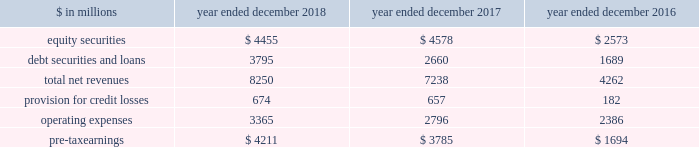The goldman sachs group , inc .
And subsidiaries management 2019s discussion and analysis net revenues in equities were $ 6.60 billion , 4% ( 4 % ) lower than 2016 , primarily due to lower commissions and fees , reflecting a decline in our listed cash equity volumes in the u.s .
Market volumes in the u.s .
Also declined .
In addition , net revenues in equities client execution were lower , reflecting lower net revenues in derivatives , partially offset by higher net revenues in cash products .
Net revenues in securities services were essentially unchanged .
Operating expenses were $ 9.69 billion for 2017 , essentially unchanged compared with 2016 , due to decreased compensation and benefits expenses , reflecting lower net revenues , largely offset by increased technology expenses , reflecting higher expenses related to cloud-based services and software depreciation , and increased consulting costs .
Pre-tax earnings were $ 2.21 billion in 2017 , 54% ( 54 % ) lower than 2016 .
Investing & lending investing & lending includes our investing activities and the origination of loans , including our relationship lending activities , to provide financing to clients .
These investments and loans are typically longer-term in nature .
We make investments , some of which are consolidated , including through our merchant banking business and our special situations group , in debt securities and loans , public and private equity securities , infrastructure and real estate entities .
Some of these investments are made indirectly through funds that we manage .
We also make unsecured loans through our digital platform , marcus : by goldman sachs and secured loans through our digital platform , goldman sachs private bank select .
The table below presents the operating results of our investing & lending segment. .
Operating environment .
During 2018 , our investments in private equities benefited from company-specific events , including sales , and strong corporate performance , while investments in public equities reflected losses , as global equity prices generally decreased .
Results for our investments in debt securities and loans reflected continued growth in loans receivables , resulting in higher net interest income .
If macroeconomic concerns negatively affect corporate performance or the origination of loans , or if global equity prices continue to decline , net revenues in investing & lending would likely be negatively impacted .
During 2017 , generally higher global equity prices and tighter credit spreads contributed to a favorable environment for our equity and debt investments .
Results also reflected net gains from company-specific events , including sales , and corporate performance .
2018 versus 2017 .
Net revenues in investing & lending were $ 8.25 billion for 2018 , 14% ( 14 % ) higher than 2017 .
Net revenues in equity securities were $ 4.46 billion , 3% ( 3 % ) lower than 2017 , reflecting net losses from investments in public equities ( 2018 included $ 183 million of net losses ) compared with net gains in the prior year , partially offset by significantly higher net gains from investments in private equities ( 2018 included $ 4.64 billion of net gains ) , driven by company-specific events , including sales , and corporate performance .
For 2018 , 60% ( 60 % ) of the net revenues in equity securities were generated from corporate investments and 40% ( 40 % ) were generated from real estate .
Net revenues in debt securities and loans were $ 3.80 billion , 43% ( 43 % ) higher than 2017 , primarily driven by significantly higher net interest income .
2018 included net interest income of approximately $ 2.70 billion compared with approximately $ 1.80 billion in 2017 .
Provision for credit losses was $ 674 million for 2018 , compared with $ 657 million for 2017 , as the higher provision for credit losses primarily related to consumer loan growth in 2018 was partially offset by an impairment of approximately $ 130 million on a secured loan in 2017 .
Operating expenses were $ 3.37 billion for 2018 , 20% ( 20 % ) higher than 2017 , primarily due to increased expenses related to consolidated investments and our digital lending and deposit platform , and increased compensation and benefits expenses , reflecting higher net revenues .
Pre-tax earnings were $ 4.21 billion in 2018 , 11% ( 11 % ) higher than 2017 versus 2016 .
Net revenues in investing & lending were $ 7.24 billion for 2017 , 70% ( 70 % ) higher than 2016 .
Net revenues in equity securities were $ 4.58 billion , 78% ( 78 % ) higher than 2016 , primarily reflecting a significant increase in net gains from private equities ( 2017 included $ 3.82 billion of net gains ) , which were positively impacted by company-specific events and corporate performance .
In addition , net gains from public equities ( 2017 included $ 762 million of net gains ) were significantly higher , as global equity prices increased during the year .
For 2017 , 64% ( 64 % ) of the net revenues in equity securities were generated from corporate investments and 36% ( 36 % ) were generated from real estate .
Net revenues in debt securities and loans were $ 2.66 billion , 57% ( 57 % ) higher than 2016 , reflecting significantly higher net interest income ( 2017 included approximately $ 1.80 billion of net interest income ) .
60 goldman sachs 2018 form 10-k .
What is the growth rate in pre-tax earnings in 2018? 
Computations: ((4211 - 3785) / 3785)
Answer: 0.11255. 